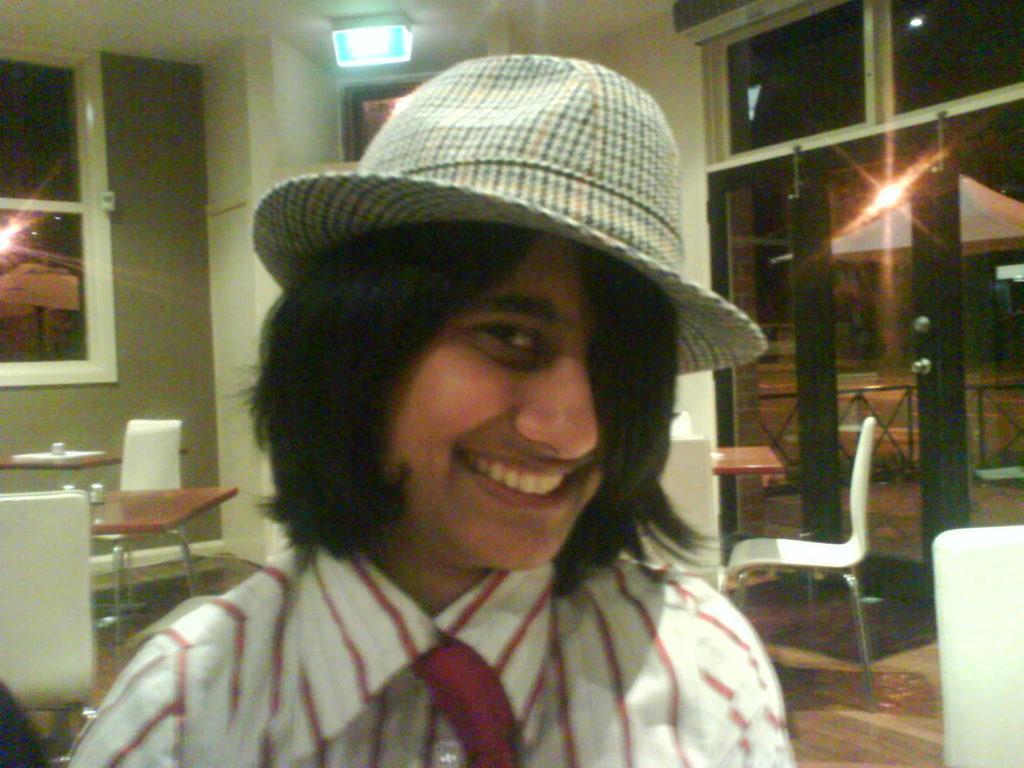Please provide a concise description of this image. In the image in center there is a person,he is smiling which we can see on his face he is wearing cap. And the left corner there is a table and chairs and wall with glass window. 